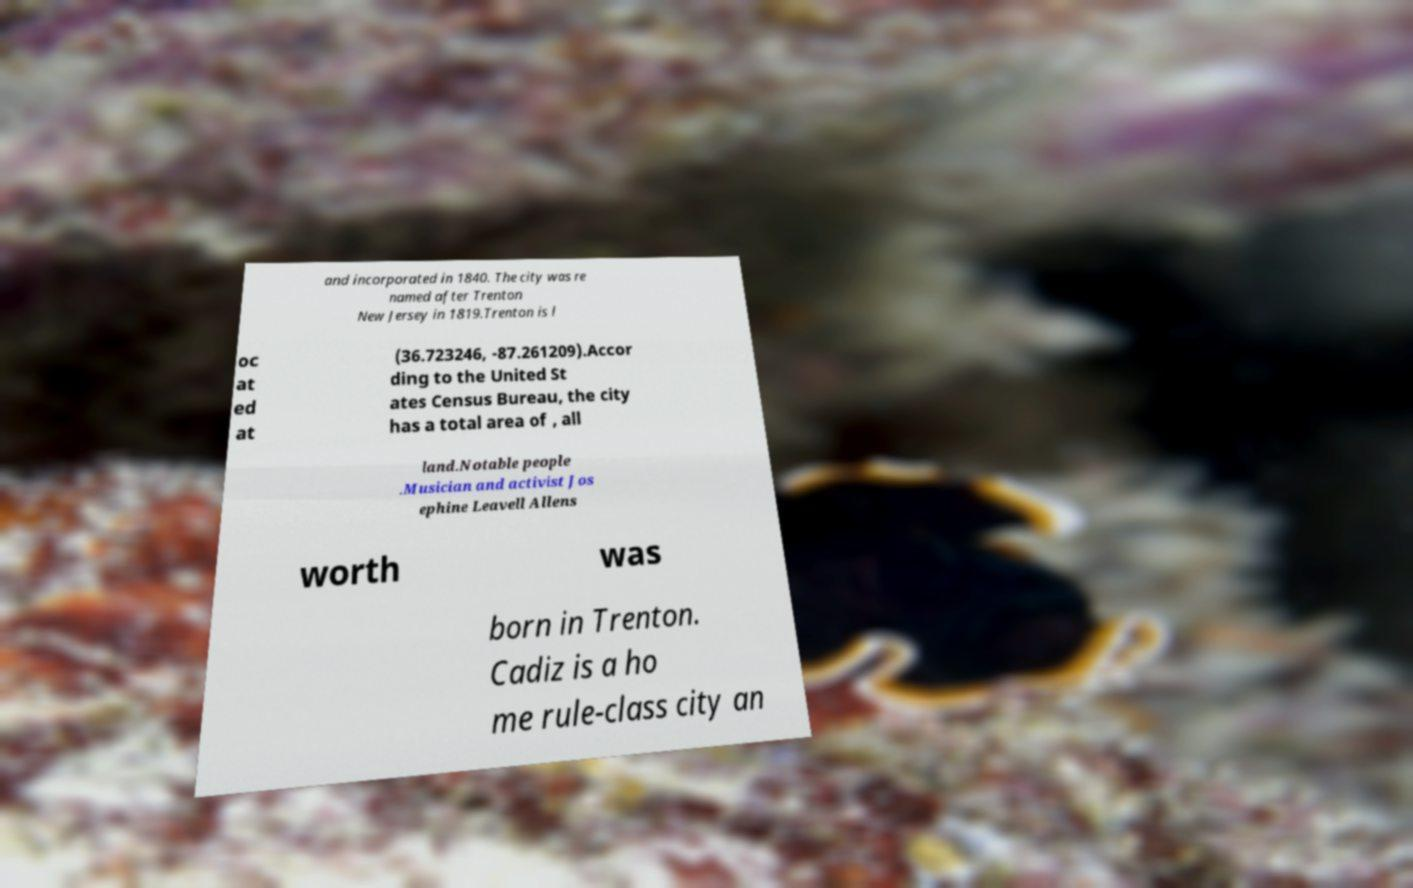Could you extract and type out the text from this image? and incorporated in 1840. The city was re named after Trenton New Jersey in 1819.Trenton is l oc at ed at (36.723246, -87.261209).Accor ding to the United St ates Census Bureau, the city has a total area of , all land.Notable people .Musician and activist Jos ephine Leavell Allens worth was born in Trenton. Cadiz is a ho me rule-class city an 